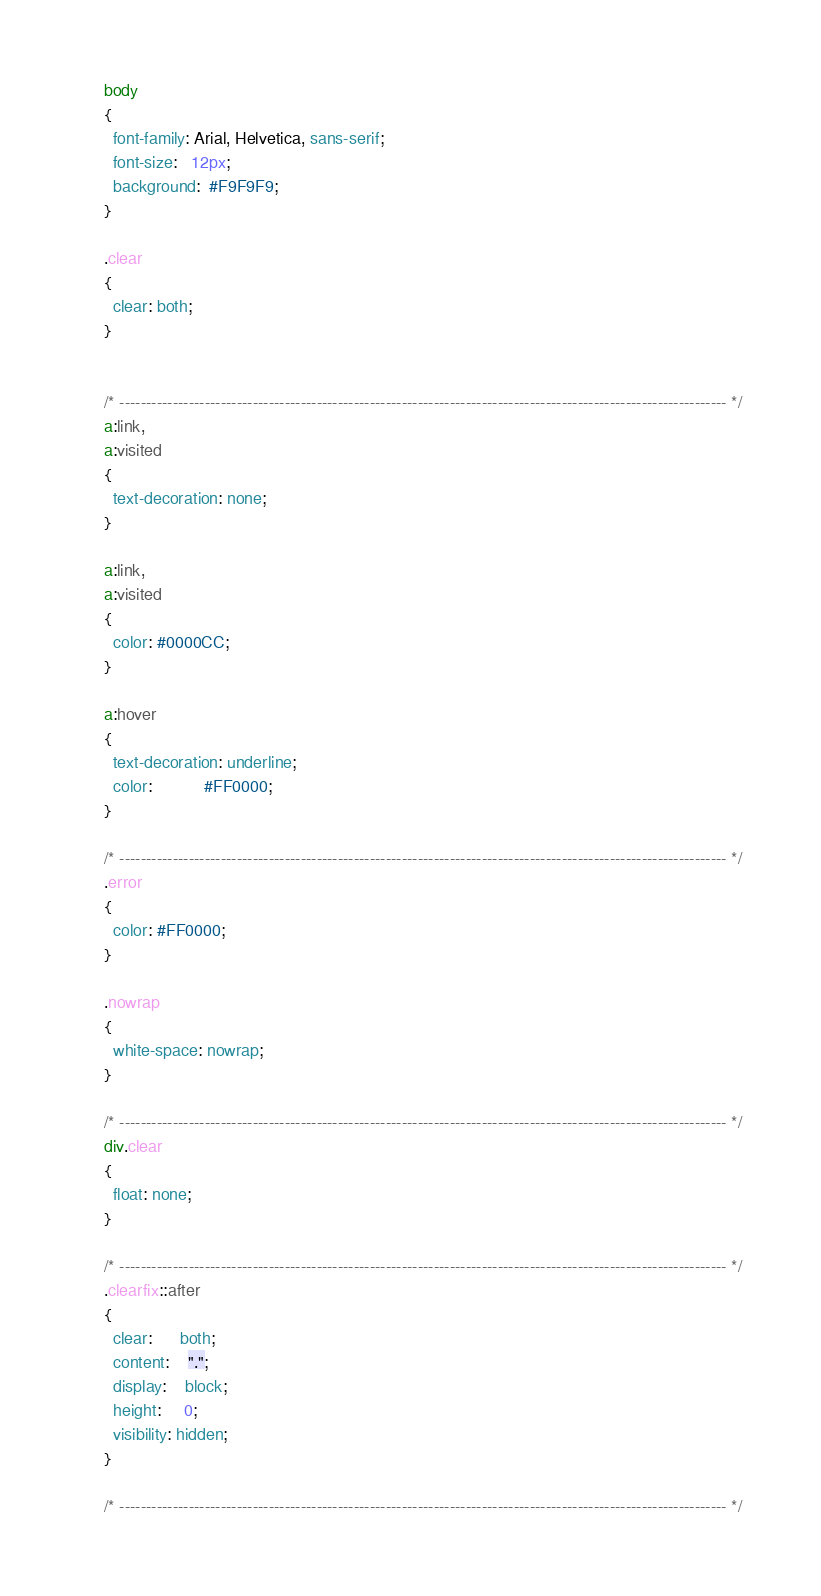<code> <loc_0><loc_0><loc_500><loc_500><_CSS_>body
{
  font-family: Arial, Helvetica, sans-serif;
  font-size:   12px;
  background:  #F9F9F9;
}

.clear
{
  clear: both;
}


/* ------------------------------------------------------------------------------------------------------------------ */
a:link,
a:visited
{
  text-decoration: none;
}

a:link,
a:visited
{
  color: #0000CC;
}

a:hover
{
  text-decoration: underline;
  color:           #FF0000;
}

/* ------------------------------------------------------------------------------------------------------------------ */
.error
{
  color: #FF0000;
}

.nowrap
{
  white-space: nowrap;
}

/* ------------------------------------------------------------------------------------------------------------------ */
div.clear
{
  float: none;
}

/* ------------------------------------------------------------------------------------------------------------------ */
.clearfix::after
{
  clear:      both;
  content:    ".";
  display:    block;
  height:     0;
  visibility: hidden;
}

/* ------------------------------------------------------------------------------------------------------------------ */
</code> 